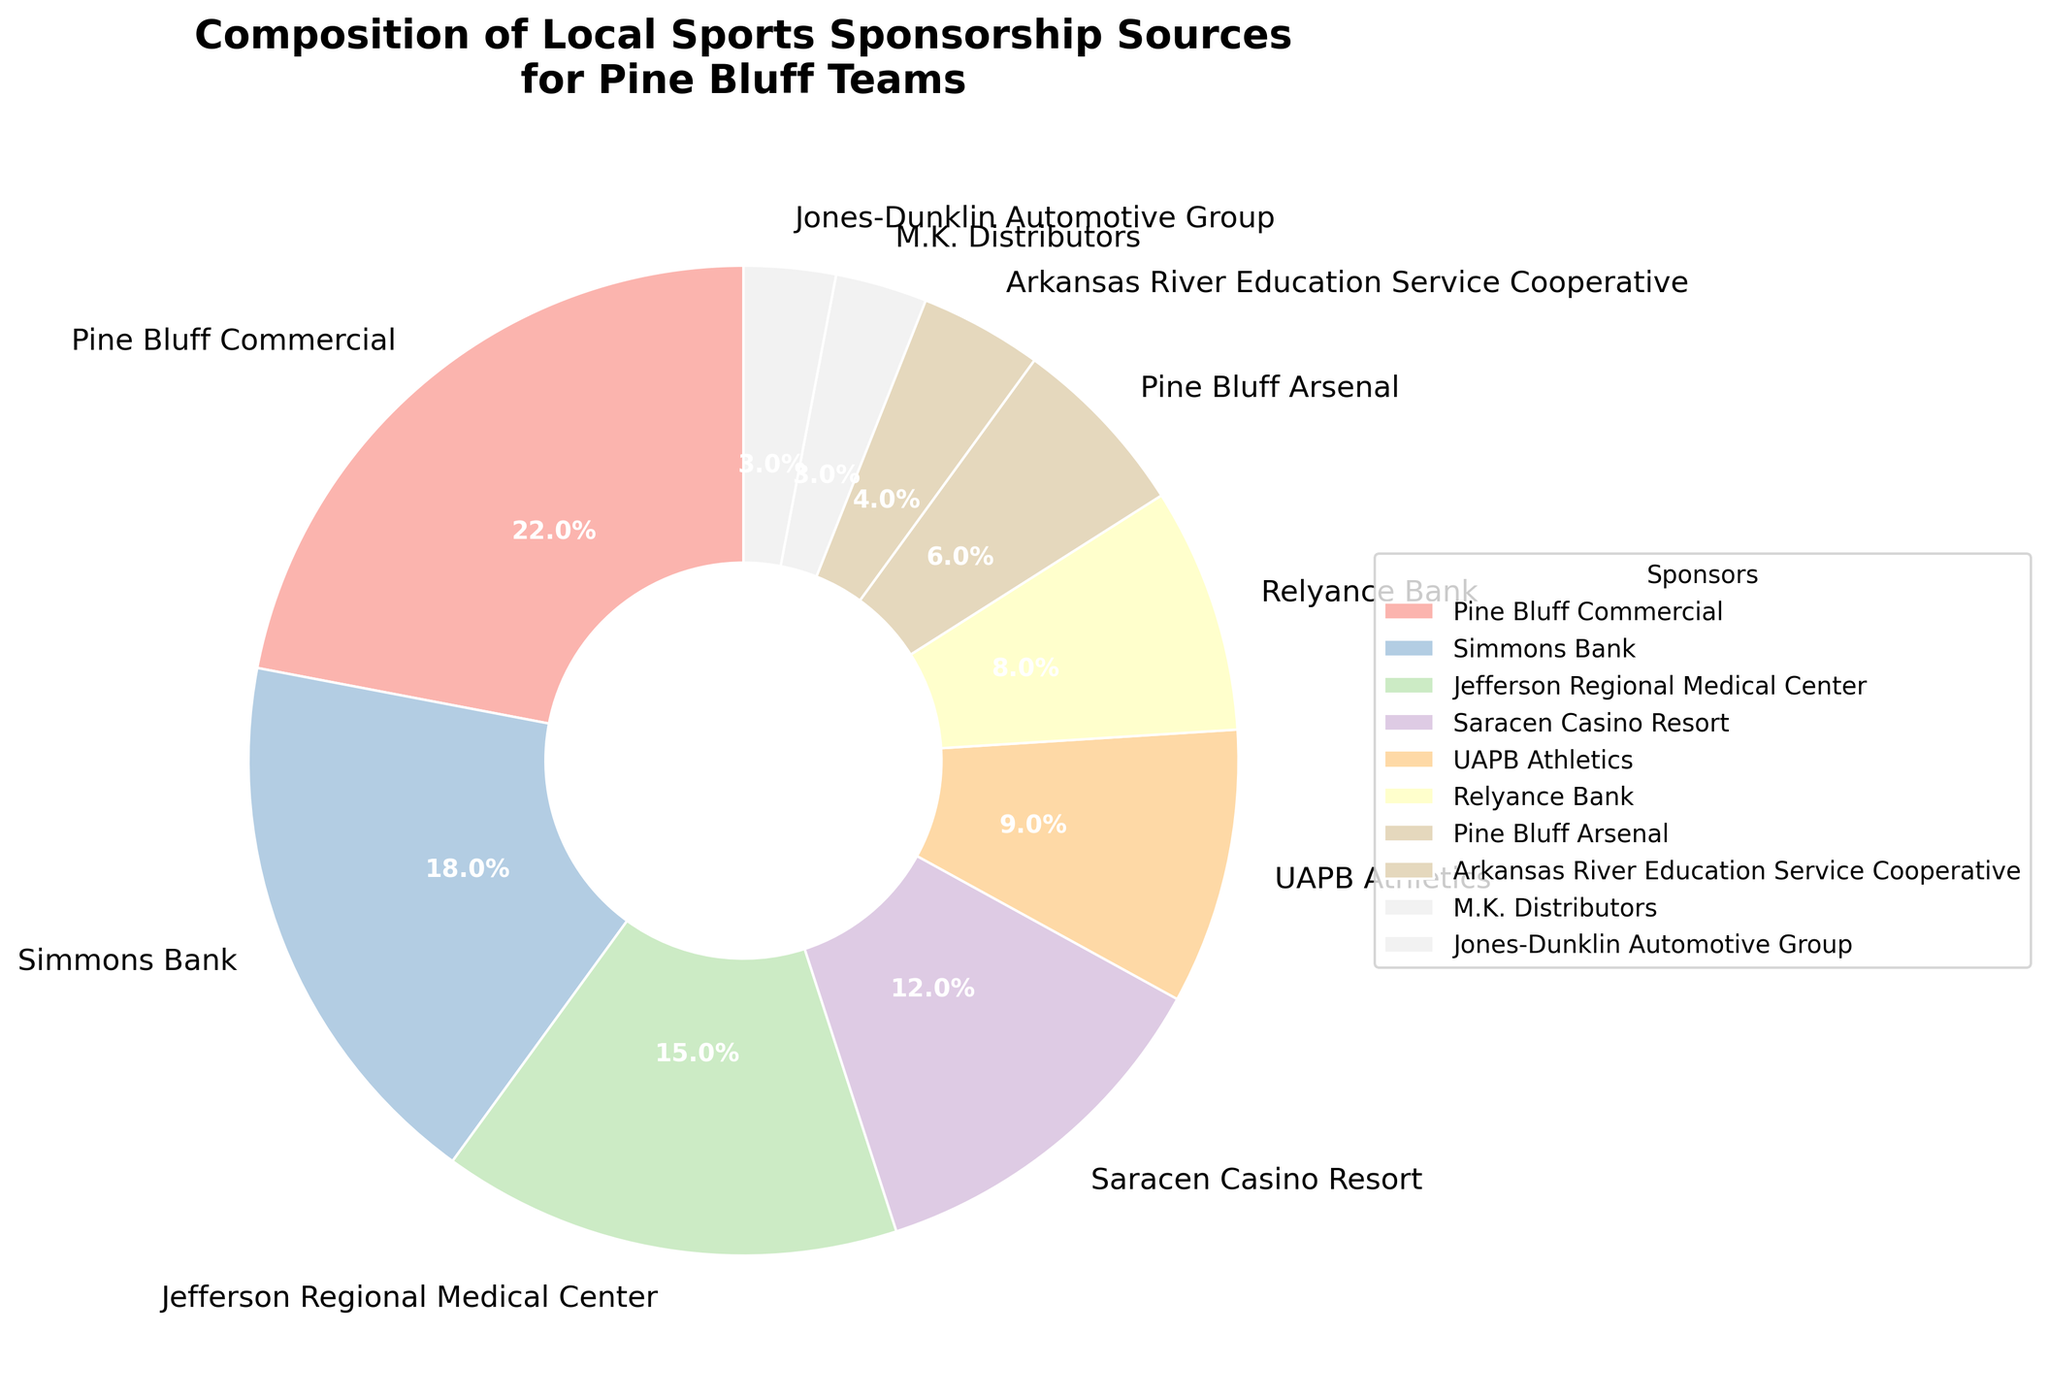What is the combined percentage of sponsorship from Simmons Bank, Jefferson Regional Medical Center, and Saracen Casino Resort? To find the combined percentage, add the individual percentages of the three sponsors: Simmons Bank (18%), Jefferson Regional Medical Center (15%), and Saracen Casino Resort (12%). The sum is 18% + 15% + 12% = 45%.
Answer: 45% Which sponsor has the smallest contribution to the sports teams' funding? Examine the pie chart and look for the section with the smallest percentage. M.K. Distributors and Jones-Dunklin Automotive Group both contribute 3%, but since both are at the lowest value, either one can be considered the smallest contributor.
Answer: M.K. Distributors / Jones-Dunklin Automotive Group Is the contribution from Pine Bluff Commercial greater than the contributions from Relyance Bank and Pine Bluff Arsenal combined? First, sum the contributions from Relyance Bank (8%) and Pine Bluff Arsenal (6%), which equals 14%. Now compare it to Pine Bluff Commercial's contribution of 22%. Since 22% is greater than 14%, Pine Bluff Commercial's contribution is greater.
Answer: Yes By how much does the top sponsor's contribution exceed the average contribution of all sponsors? Calculate the average contribution by summing all the percentages (22% + 18% + 15% + 12% + 9% + 8% + 6% + 4% + 3% + 3%) which equals 100%, and divide by the number of sponsors (10). The average is 100% / 10 = 10%. Pine Bluff Commercial contributes 22%, which is 22% - 10% = 12% greater than the average.
Answer: 12% What is the relative percentage difference between Simmons Bank and UAPB Athletics? Subtract the smaller percentage (UAPB Athletics at 9%) from the larger percentage (Simmons Bank at 18%) to get the absolute difference: 18% - 9% = 9%. Then, to find the relative difference, divide the absolute difference by UAPB Athletics' percentage: 9% / 9% = 1 or 100%.
Answer: 100% Which sponsor occupies the largest section in the pie chart, and what is its percentage? The largest section in the pie chart corresponds to the sponsor with the highest percentage. This is Pine Bluff Commercial, which contributes 22%.
Answer: Pine Bluff Commercial, 22% What is the visual characteristic of the slice representing Saracen Casino Resort in terms of its relative size compared to other slices? Saracen Casino Resort contributes 12%. Visually, this slice is medium-sized, larger than those representing Relyance Bank (8%) and smaller sponsors, but smaller than those representing higher contributions like Pine Bluff Commercial (22%) and Simmons Bank (18%).
Answer: Medium-sized How much more percentage is contributed by Pine Bluff Commercial compared to Jefferson Regional Medical Center? Subtract the percentage of Jefferson Regional Medical Center (15%) from Pine Bluff Commercial (22%) to get the difference: 22% - 15% = 7%.
Answer: 7% Which two sponsors have the same percentage contribution, and what is that percentage? Look for sponsors with equal-sized slices in the pie chart. M.K. Distributors and Jones-Dunklin Automotive Group both contribute 3%.
Answer: M.K. Distributors & Jones-Dunklin Automotive Group, 3% 